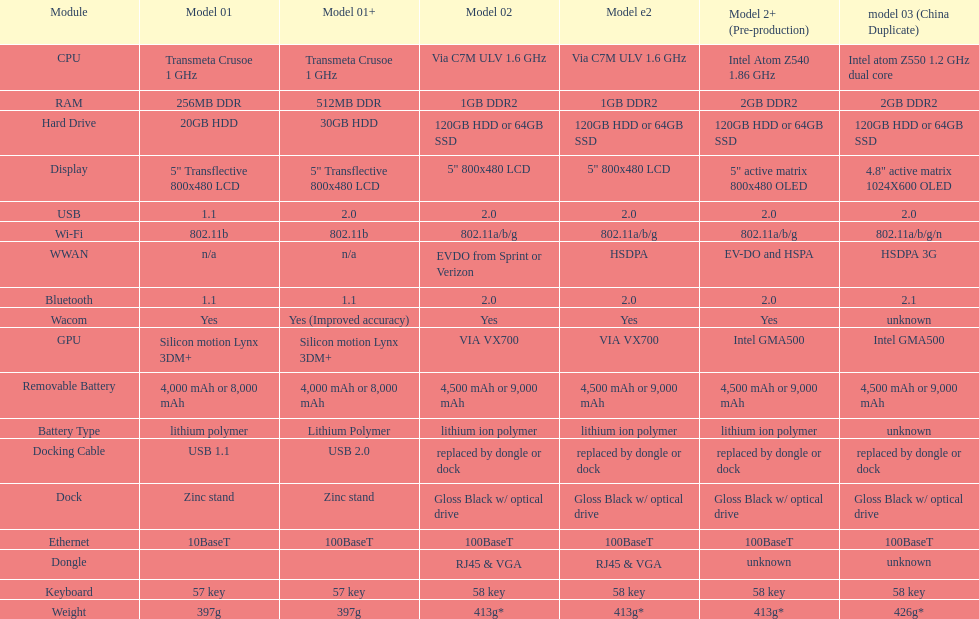Which model offers a bigger hard drive: model 01 or model 02? Model 02. 